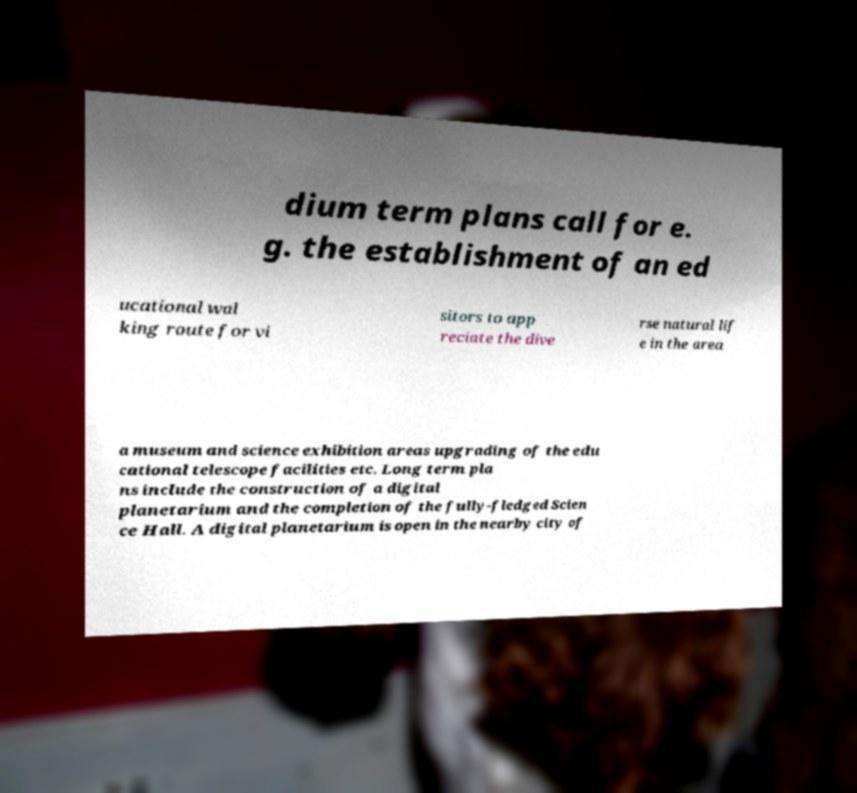Please identify and transcribe the text found in this image. dium term plans call for e. g. the establishment of an ed ucational wal king route for vi sitors to app reciate the dive rse natural lif e in the area a museum and science exhibition areas upgrading of the edu cational telescope facilities etc. Long term pla ns include the construction of a digital planetarium and the completion of the fully-fledged Scien ce Hall. A digital planetarium is open in the nearby city of 